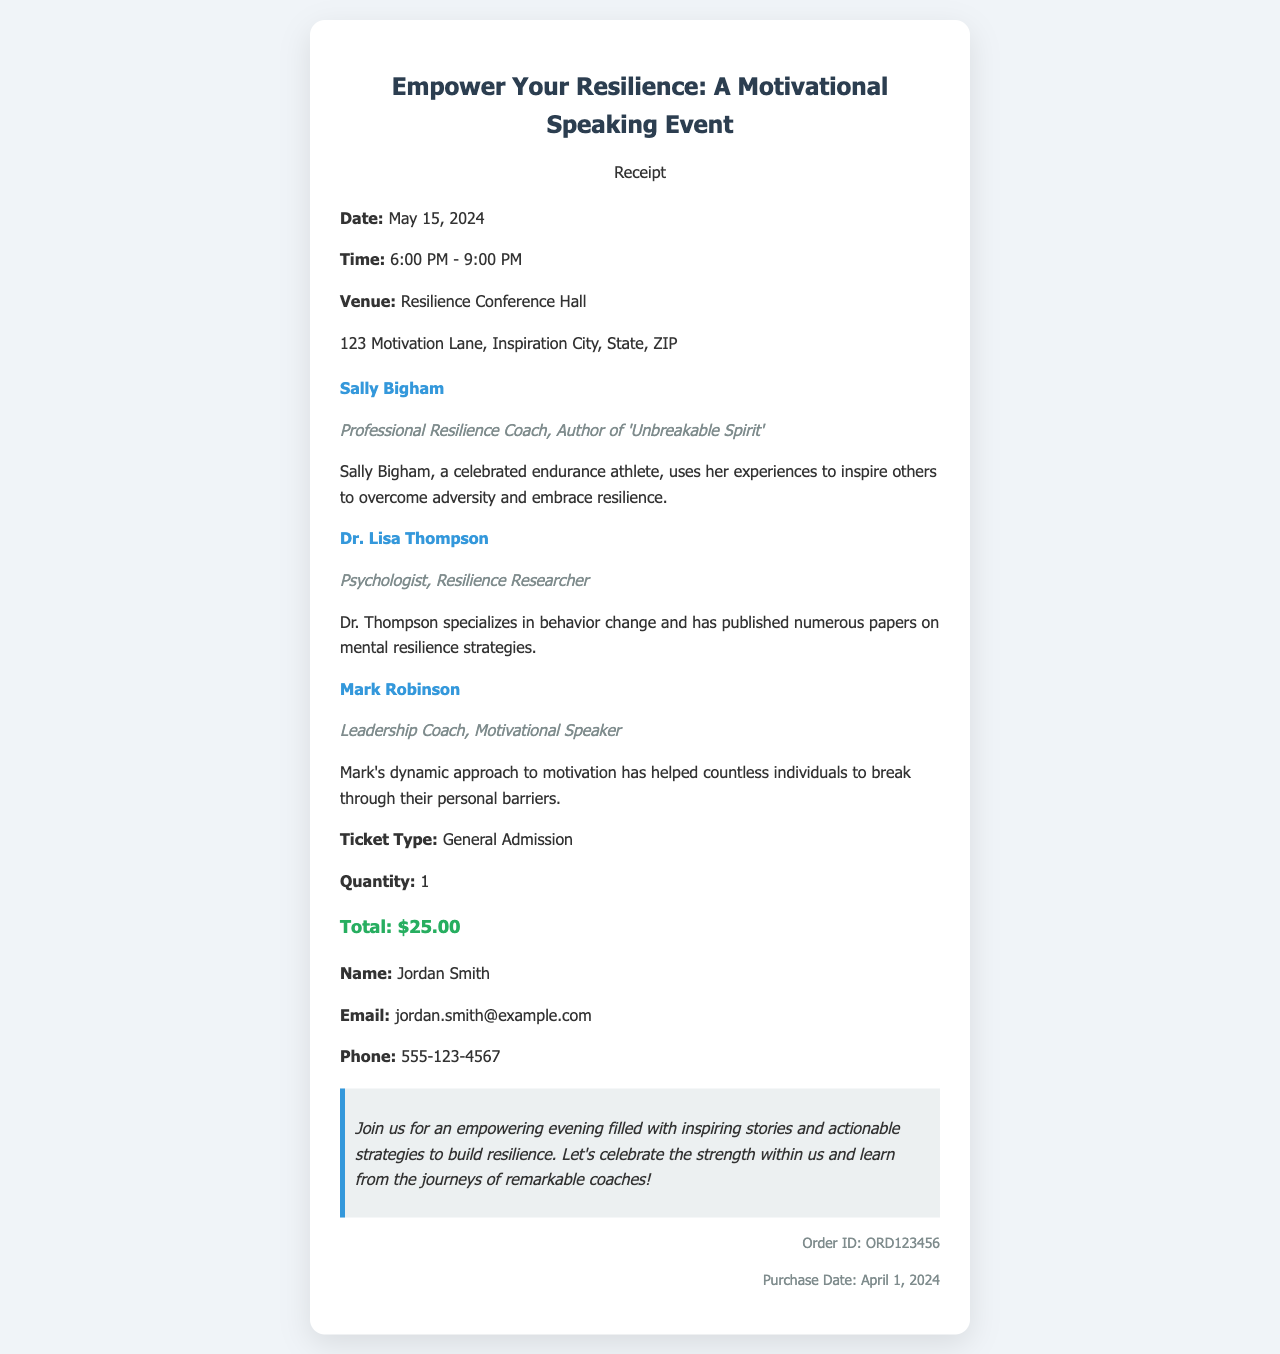What is the date of the event? The date of the event is clearly stated in the event details section of the receipt as May 15, 2024.
Answer: May 15, 2024 Who is the main speaker? The main speaker is identified in the speaker section as Sally Bigham, who is highlighted with her credentials.
Answer: Sally Bigham What is the ticket price? The ticket price is specified in the ticket info section as a total of $25.00.
Answer: $25.00 What is the venue of the event? The venue is mentioned in the event details section as Resilience Conference Hall, which is essential information for attendees.
Answer: Resilience Conference Hall How many speakers are listed in the document? The document lists three speakers, which can be counted from the speaker sections provided.
Answer: 3 What is the order ID? The order ID is mentioned at the bottom of the receipt, providing a reference for the purchase.
Answer: ORD123456 What type of ticket was purchased? The ticket type is specified in the ticket information section as General Admission.
Answer: General Admission What is the name of the buyer? The buyer's name is indicated in the buyer info section as Jordan Smith.
Answer: Jordan Smith What is the event's time duration? The time duration is noted in the event details section, indicating the event runs from 6:00 PM to 9:00 PM.
Answer: 6:00 PM - 9:00 PM 